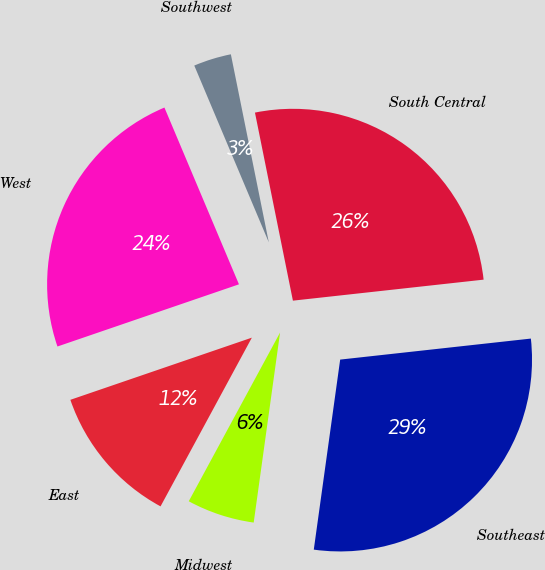Convert chart. <chart><loc_0><loc_0><loc_500><loc_500><pie_chart><fcel>East<fcel>Midwest<fcel>Southeast<fcel>South Central<fcel>Southwest<fcel>West<nl><fcel>11.85%<fcel>5.7%<fcel>28.94%<fcel>26.42%<fcel>3.18%<fcel>23.9%<nl></chart> 